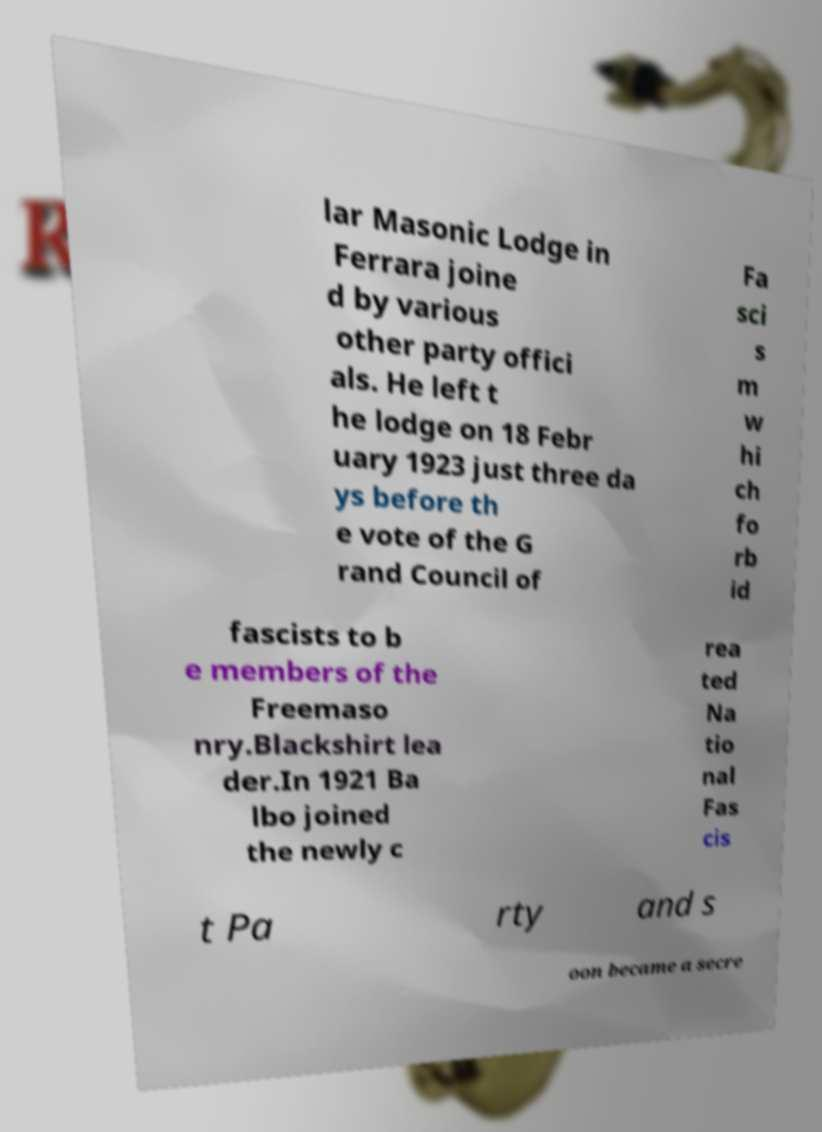Could you extract and type out the text from this image? lar Masonic Lodge in Ferrara joine d by various other party offici als. He left t he lodge on 18 Febr uary 1923 just three da ys before th e vote of the G rand Council of Fa sci s m w hi ch fo rb id fascists to b e members of the Freemaso nry.Blackshirt lea der.In 1921 Ba lbo joined the newly c rea ted Na tio nal Fas cis t Pa rty and s oon became a secre 